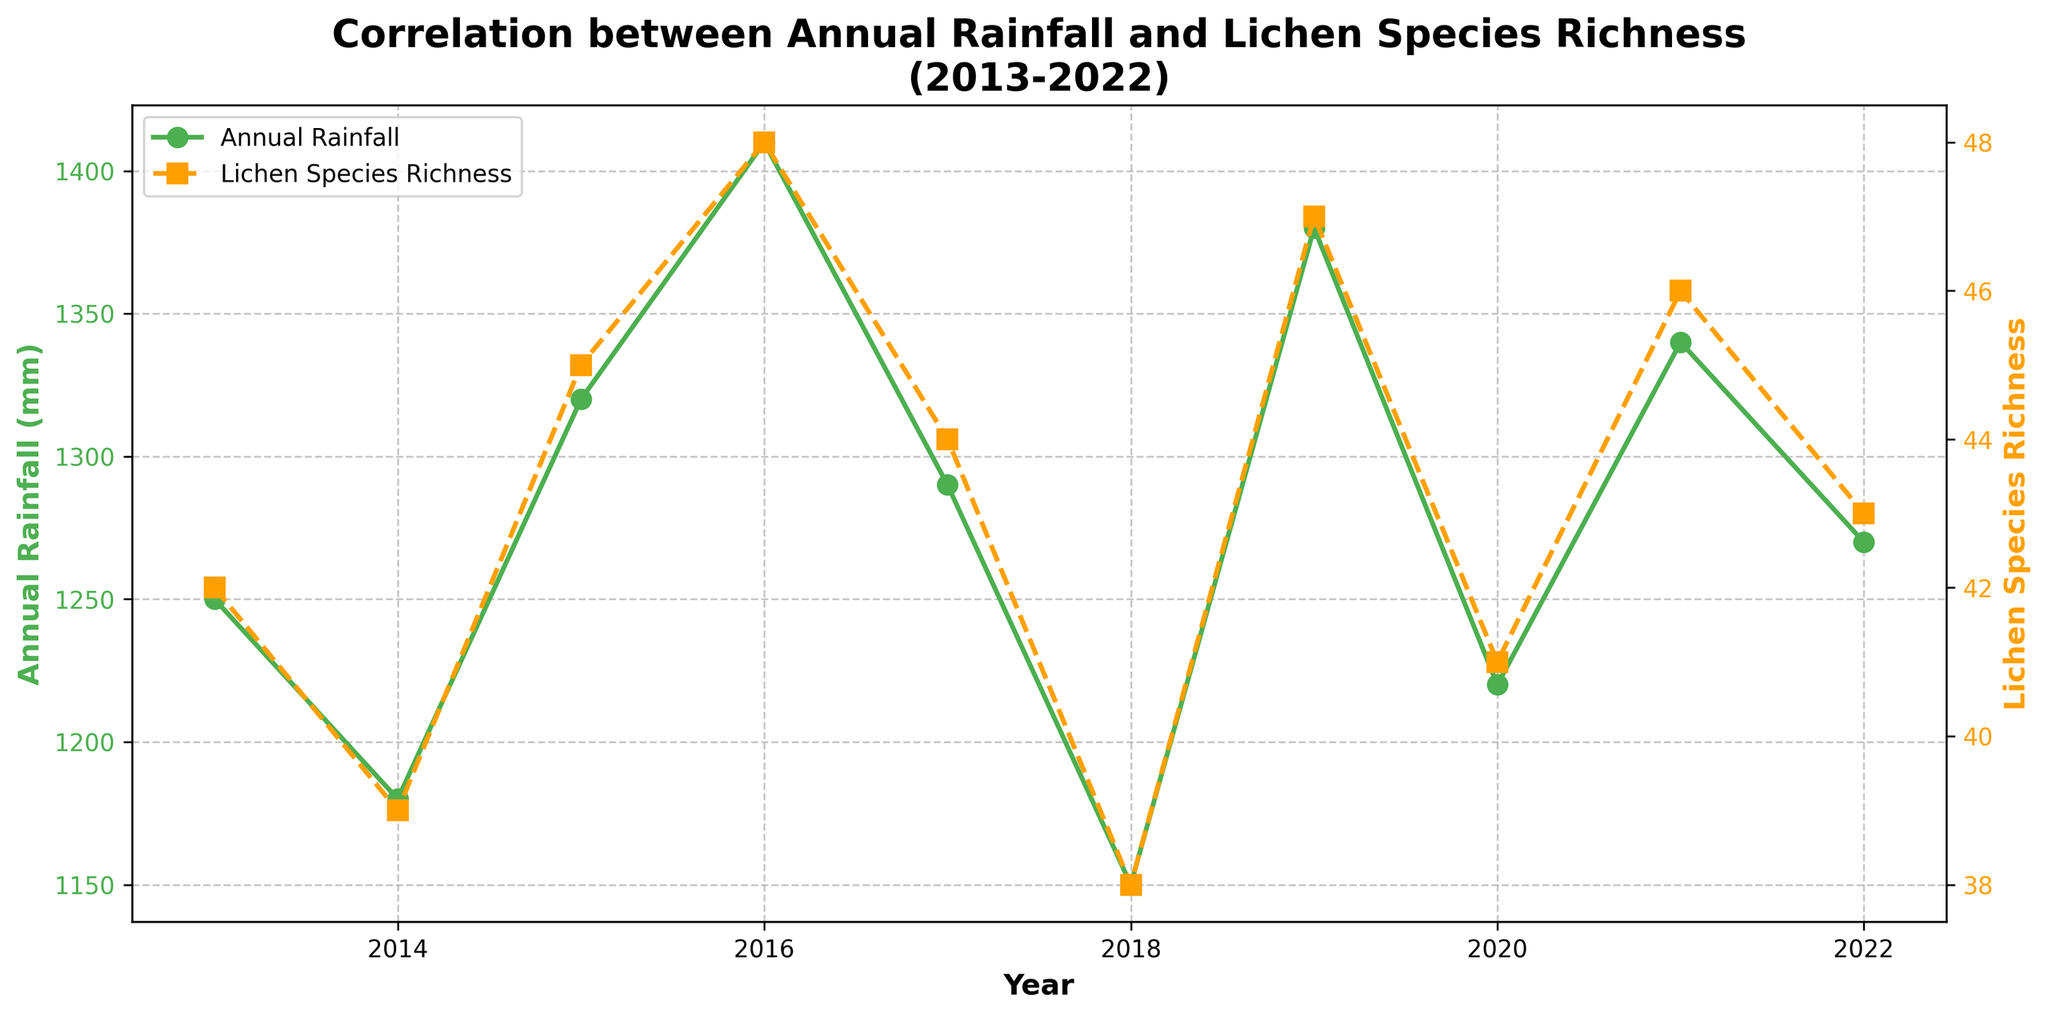what is the average annual rainfall over the 10 years? Sum all the annual rainfall values: 1250 + 1180 + 1320 + 1410 + 1290 + 1150 + 1380 + 1220 + 1340 + 1270 = 12810. Divide by the number of years (10): 12810 / 10 = 1281 mm.
Answer: 1281 mm In which year did the lichen species richness peak, and what was its value? Identify the highest point on the Lichen Species Richness graph. The peak value is 48 in 2016.
Answer: 2016, 48 Compare the annual rainfall and lichen species richness for the year 2014. Which one was higher? For 2014, Annual Rainfall was 1180 mm and Lichen Species Richness was 39. Since 1180 mm is greater than 39, Annual Rainfall was higher.
Answer: Annual Rainfall What is the difference in lichen species richness between the years 2015 and 2018? Calculate the difference between the Lichen Species Richness in 2015 (45) and 2018 (38): 45 - 38 = 7.
Answer: 7 Is there a general trend in how lichen species richness responds to changes in annual rainfall? Observing the overall pattern across the years, higher annual rainfall tends to correspond with higher lichen species richness, suggesting a positive correlation.
Answer: Positive correlation What was the lowest annual rainfall recorded in the dataset, and in which year? Identify the minimum value in the Annual Rainfall data. The lowest annual rainfall is 1150 mm, recorded in 2018.
Answer: 2018, 1150 mm Which year showed the greatest increase in lichen species richness compared to the previous year? Look at the differences in Lichen Species Richness between consecutive years. The largest increase is from 2013 (42) to 2014 (45), an increase of 3.
Answer: 2014 Calculate the average lichen species richness for the years with annual rainfall greater than 1300 mm. Identify the years with rainfall greater than 1300 mm (2015, 2016, 2019, 2021). Their Lichen Species Richness values are 45, 48, 47, and 46, respectively. Compute the average: (45 + 48 + 47 + 46) / 4 = 186 / 4 = 46.5.
Answer: 46.5 Which year experienced the second highest annual rainfall, and what was the corresponding lichen species richness? Identify the second highest annual rainfall value, which is 1380 mm in 2019. The corresponding Lichen Species Richness is 47.
Answer: 2019, 47 